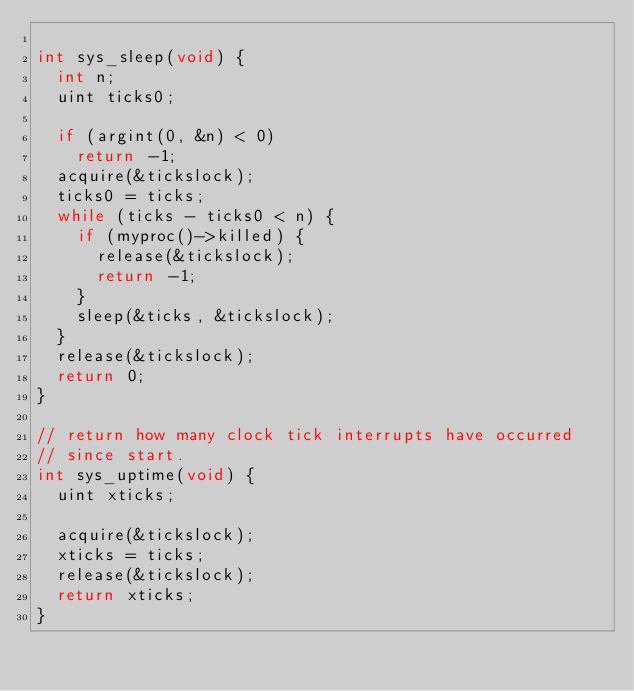<code> <loc_0><loc_0><loc_500><loc_500><_C_>
int sys_sleep(void) {
	int n;
	uint ticks0;

	if (argint(0, &n) < 0)
		return -1;
	acquire(&tickslock);
	ticks0 = ticks;
	while (ticks - ticks0 < n) {
		if (myproc()->killed) {
			release(&tickslock);
			return -1;
		}
		sleep(&ticks, &tickslock);
	}
	release(&tickslock);
	return 0;
}

// return how many clock tick interrupts have occurred
// since start.
int sys_uptime(void) {
	uint xticks;

	acquire(&tickslock);
	xticks = ticks;
	release(&tickslock);
	return xticks;
}
</code> 